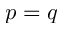<formula> <loc_0><loc_0><loc_500><loc_500>p = q</formula> 